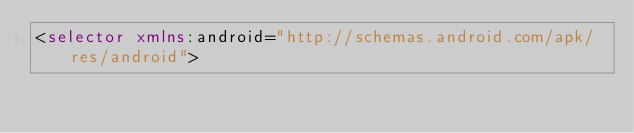Convert code to text. <code><loc_0><loc_0><loc_500><loc_500><_XML_><selector xmlns:android="http://schemas.android.com/apk/res/android"></code> 